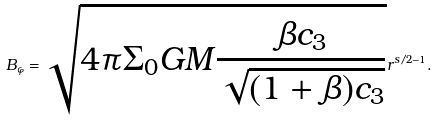Convert formula to latex. <formula><loc_0><loc_0><loc_500><loc_500>B _ { \varphi } = \sqrt { 4 \pi \Sigma _ { 0 } G M \frac { \beta c _ { 3 } } { \sqrt { ( 1 + \beta ) c _ { 3 } } } } r ^ { s / 2 - 1 } .</formula> 